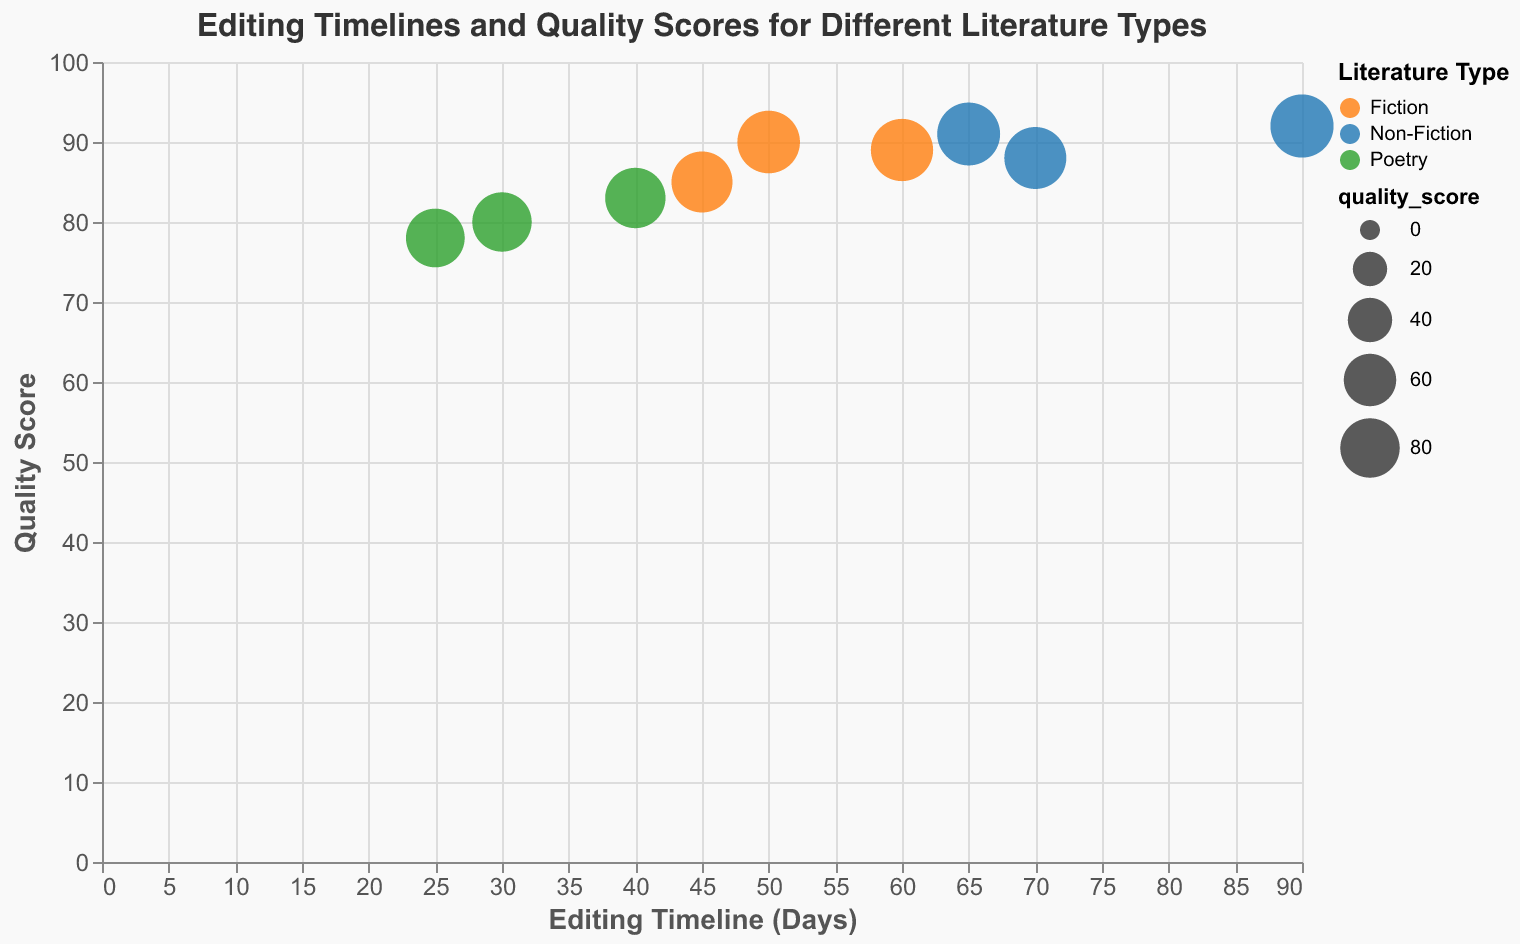Which work has the highest quality score among Fiction titles? Look at the Fiction type bubbles and identify the one with the highest position on the y-axis, which represents the quality score. "1984" has the highest quality score of 90 among Fiction titles.
Answer: 1984 How many works of Non-Fiction are displayed in the figure? Count the number of bubbles colored identifiably for Non-Fiction (blue) in the figure. There are three Non-Fiction works.
Answer: 3 What is the average editing timeline for Poetry types? Find the editing timeline days for all Poetry works and calculate the average: (30 + 25 + 40) / 3 = 31.67 days.
Answer: 31.67 days Which type of literature has the highest average quality score? Calculate the average quality score for each type:
- Fiction: (85 + 89 + 90) / 3 ≈ 88
- Non-Fiction: (92 + 88 + 91) / 3 ≈ 90.33
- Poetry: (80 + 78 + 83) / 3 ≈ 80.33
Non-Fiction has the highest average quality score.
Answer: Non-Fiction What is the range of editing timeline days for Fiction titles? Determine the minimum and maximum editing timeline days for Fiction titles: min is 45 and max is 60, so the range is 60 - 45 = 15 days.
Answer: 15 days Which work has the lowest quality score in the Poetry type? Look at the Poetry type bubbles and identify the one with the lowest position on the y-axis. "Milk and Honey" has the lowest quality score of 78 among Poetry titles.
Answer: Milk and Honey Is there a correlation between editing timeline and quality score? By observing the scatter plot, assess if there is a trend. It seems like there is a positive correlation; as editing timeline increases, quality score appears to improve. However, to be more certain, statistical analysis is needed.
Answer: Positive correlation noted Which type of literature shows the most variability in editing timelines? Calculate the range for each type:
- Fiction: 60 - 45 = 15
- Non-Fiction: 90 - 65 = 25
- Poetry: 40 - 25 = 15
Non-Fiction has the most variability in editing timelines with a range of 25 days.
Answer: Non-Fiction Are there any works with a quality score above 90? Identify the bubbles with a y-axis value (quality score) above 90. Only "Becoming" (Non-Fiction) with a quality score of 92 fits this criterion.
Answer: Becoming 